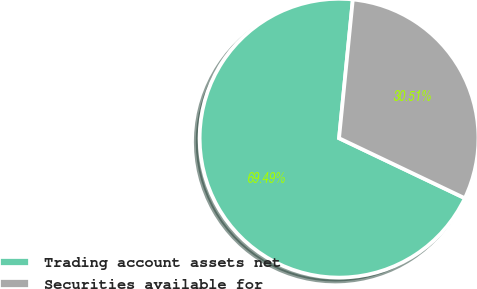Convert chart. <chart><loc_0><loc_0><loc_500><loc_500><pie_chart><fcel>Trading account assets net<fcel>Securities available for<nl><fcel>69.49%<fcel>30.51%<nl></chart> 